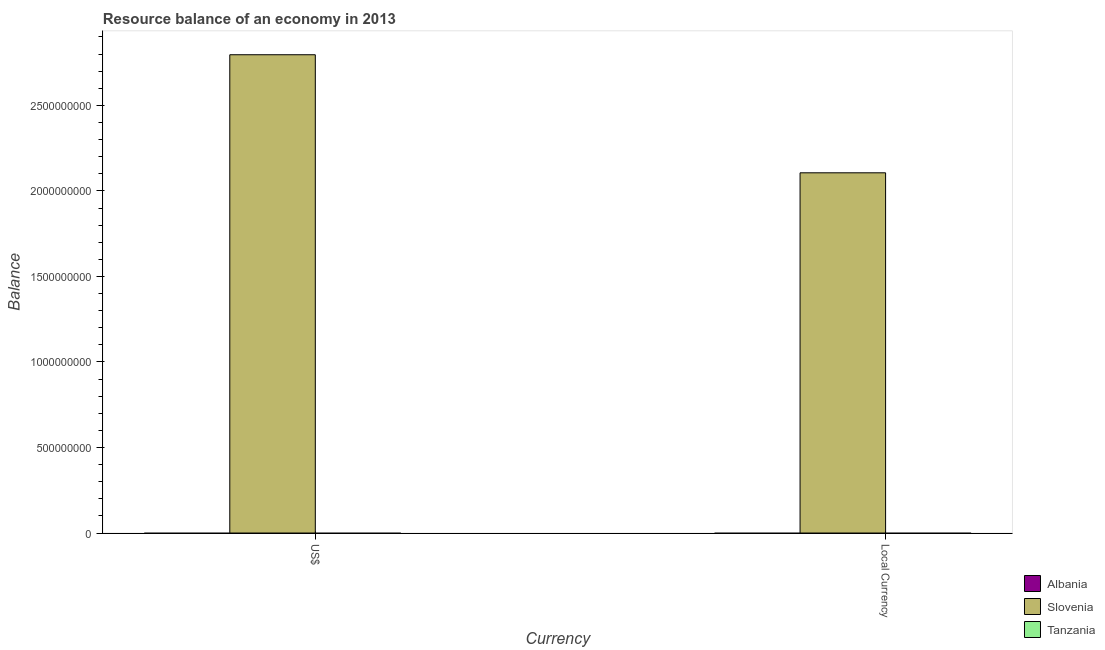How many different coloured bars are there?
Ensure brevity in your answer.  1. How many bars are there on the 2nd tick from the left?
Offer a very short reply. 1. What is the label of the 1st group of bars from the left?
Ensure brevity in your answer.  US$. What is the resource balance in us$ in Slovenia?
Offer a very short reply. 2.80e+09. Across all countries, what is the maximum resource balance in constant us$?
Offer a terse response. 2.11e+09. Across all countries, what is the minimum resource balance in constant us$?
Offer a very short reply. 0. In which country was the resource balance in us$ maximum?
Your answer should be compact. Slovenia. What is the total resource balance in us$ in the graph?
Provide a succinct answer. 2.80e+09. What is the average resource balance in constant us$ per country?
Your answer should be compact. 7.02e+08. What is the difference between the resource balance in us$ and resource balance in constant us$ in Slovenia?
Keep it short and to the point. 6.90e+08. Are all the bars in the graph horizontal?
Offer a terse response. No. How many countries are there in the graph?
Provide a succinct answer. 3. Are the values on the major ticks of Y-axis written in scientific E-notation?
Keep it short and to the point. No. How are the legend labels stacked?
Offer a terse response. Vertical. What is the title of the graph?
Provide a succinct answer. Resource balance of an economy in 2013. Does "Bhutan" appear as one of the legend labels in the graph?
Provide a succinct answer. No. What is the label or title of the X-axis?
Your answer should be compact. Currency. What is the label or title of the Y-axis?
Offer a very short reply. Balance. What is the Balance in Albania in US$?
Offer a terse response. 0. What is the Balance of Slovenia in US$?
Your answer should be very brief. 2.80e+09. What is the Balance of Albania in Local Currency?
Offer a very short reply. 0. What is the Balance of Slovenia in Local Currency?
Make the answer very short. 2.11e+09. Across all Currency, what is the maximum Balance in Slovenia?
Make the answer very short. 2.80e+09. Across all Currency, what is the minimum Balance of Slovenia?
Offer a very short reply. 2.11e+09. What is the total Balance of Slovenia in the graph?
Provide a short and direct response. 4.90e+09. What is the total Balance in Tanzania in the graph?
Offer a very short reply. 0. What is the difference between the Balance in Slovenia in US$ and that in Local Currency?
Give a very brief answer. 6.90e+08. What is the average Balance of Albania per Currency?
Offer a very short reply. 0. What is the average Balance of Slovenia per Currency?
Ensure brevity in your answer.  2.45e+09. What is the ratio of the Balance in Slovenia in US$ to that in Local Currency?
Your answer should be very brief. 1.33. What is the difference between the highest and the second highest Balance in Slovenia?
Make the answer very short. 6.90e+08. What is the difference between the highest and the lowest Balance in Slovenia?
Provide a succinct answer. 6.90e+08. 